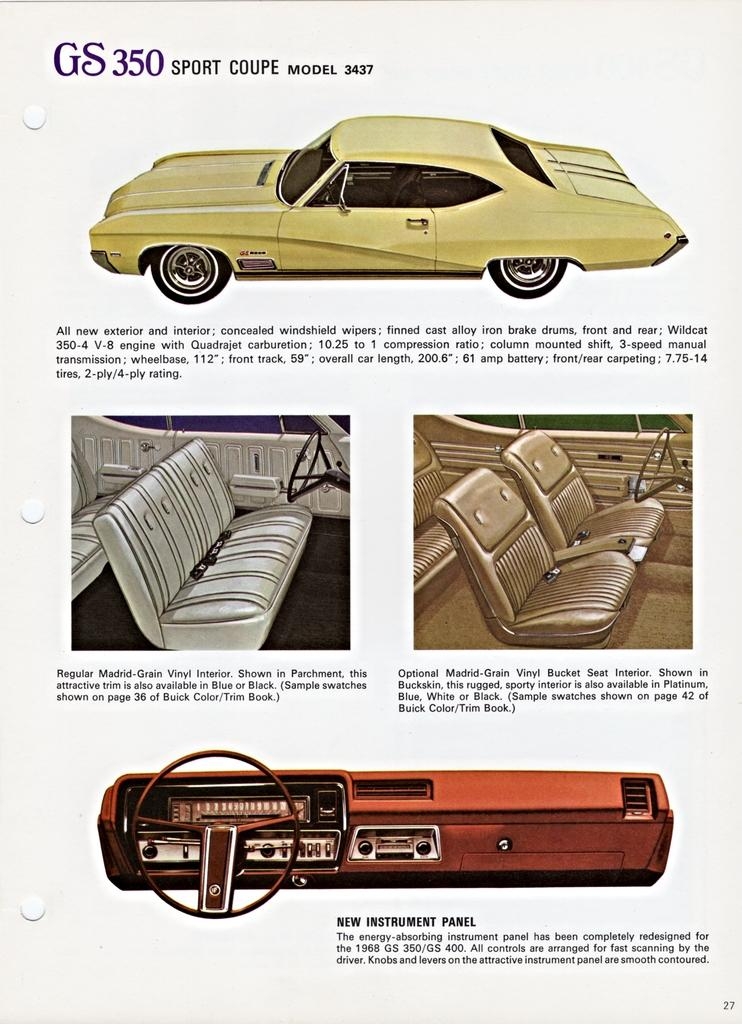What is featured on the poster in the image? There is a poster in the image, and it contains pictures of cars. What else can be seen on the poster besides the pictures of cars? There is text on the poster. Can you tell me how many cherries are depicted on the poster? There are no cherries depicted on the poster; it features pictures of cars. Is there a kitten holding an umbrella on the poster? There is no kitten or umbrella present on the poster; it only contains pictures of cars and text. 